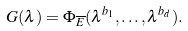<formula> <loc_0><loc_0><loc_500><loc_500>G ( \lambda ) = \Phi _ { \overline { E } } ( \lambda ^ { b _ { 1 } } , \dots , \lambda ^ { b _ { d } } ) .</formula> 